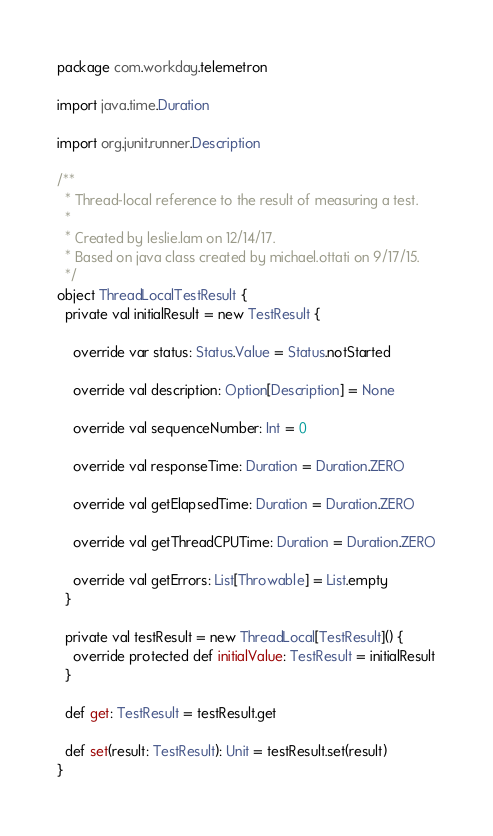Convert code to text. <code><loc_0><loc_0><loc_500><loc_500><_Scala_>package com.workday.telemetron

import java.time.Duration

import org.junit.runner.Description

/**
  * Thread-local reference to the result of measuring a test.
  *
  * Created by leslie.lam on 12/14/17.
  * Based on java class created by michael.ottati on 9/17/15.
  */
object ThreadLocalTestResult {
  private val initialResult = new TestResult {

    override var status: Status.Value = Status.notStarted

    override val description: Option[Description] = None

    override val sequenceNumber: Int = 0

    override val responseTime: Duration = Duration.ZERO

    override val getElapsedTime: Duration = Duration.ZERO

    override val getThreadCPUTime: Duration = Duration.ZERO

    override val getErrors: List[Throwable] = List.empty
  }

  private val testResult = new ThreadLocal[TestResult]() {
    override protected def initialValue: TestResult = initialResult
  }

  def get: TestResult = testResult.get

  def set(result: TestResult): Unit = testResult.set(result)
}
</code> 